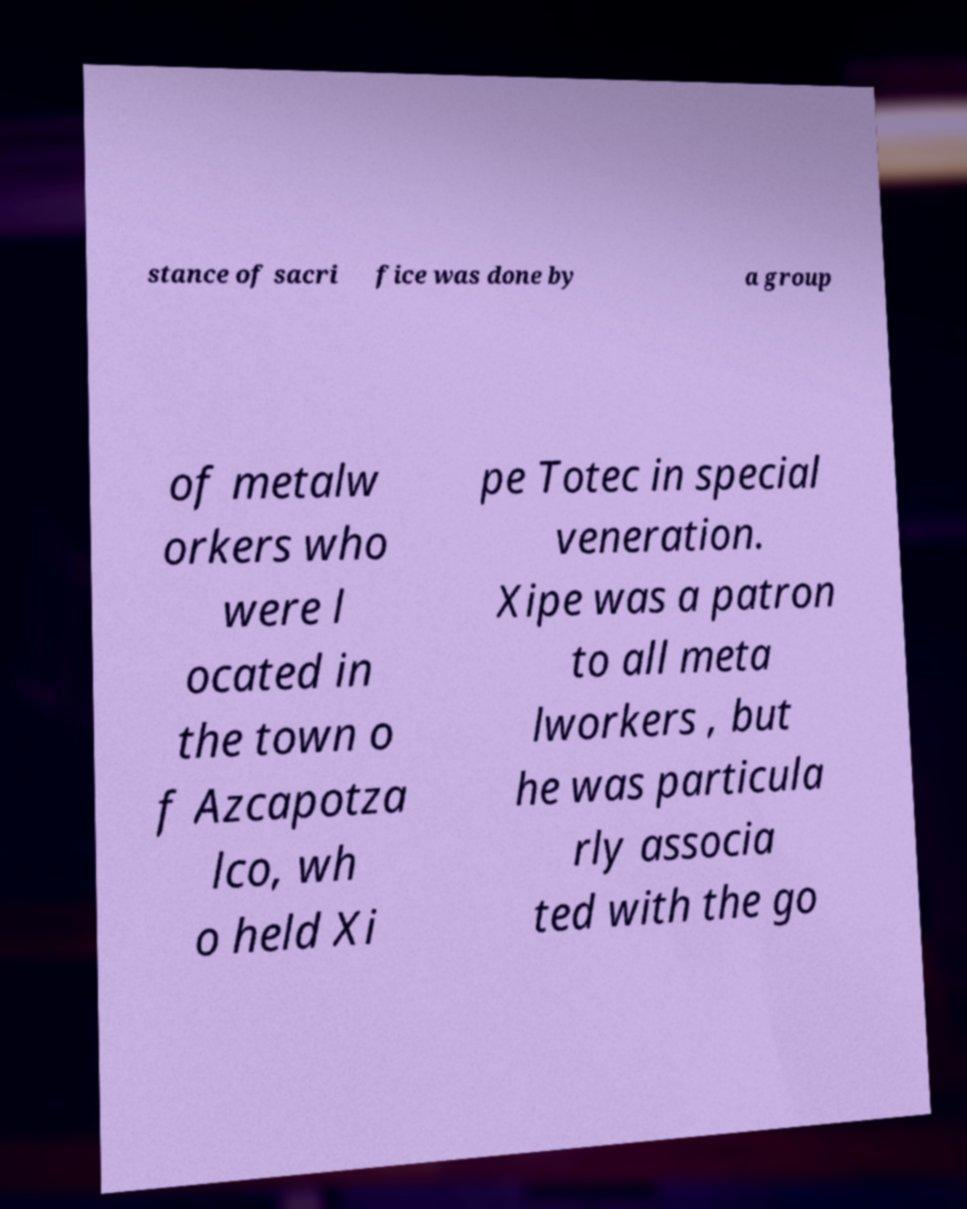Can you read and provide the text displayed in the image?This photo seems to have some interesting text. Can you extract and type it out for me? stance of sacri fice was done by a group of metalw orkers who were l ocated in the town o f Azcapotza lco, wh o held Xi pe Totec in special veneration. Xipe was a patron to all meta lworkers , but he was particula rly associa ted with the go 